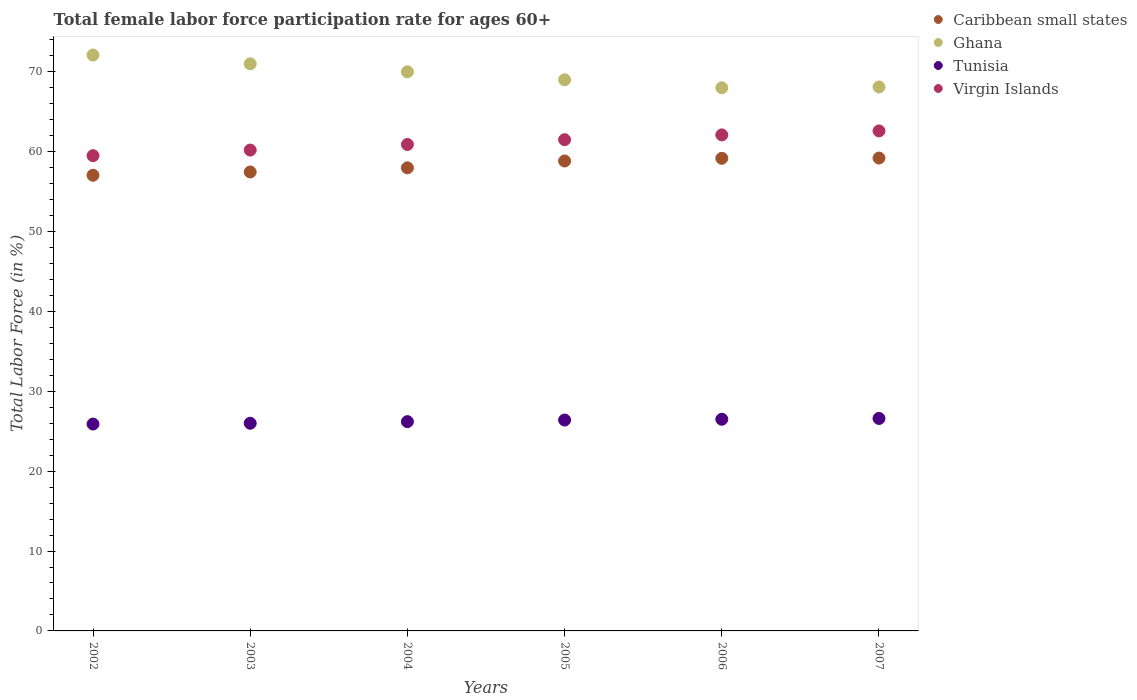How many different coloured dotlines are there?
Ensure brevity in your answer.  4. Is the number of dotlines equal to the number of legend labels?
Give a very brief answer. Yes. What is the female labor force participation rate in Ghana in 2002?
Your answer should be very brief. 72.1. Across all years, what is the maximum female labor force participation rate in Tunisia?
Offer a terse response. 26.6. In which year was the female labor force participation rate in Caribbean small states maximum?
Keep it short and to the point. 2007. What is the total female labor force participation rate in Virgin Islands in the graph?
Offer a very short reply. 366.8. What is the difference between the female labor force participation rate in Virgin Islands in 2003 and that in 2007?
Provide a succinct answer. -2.4. What is the difference between the female labor force participation rate in Caribbean small states in 2005 and the female labor force participation rate in Ghana in 2007?
Provide a short and direct response. -9.26. What is the average female labor force participation rate in Tunisia per year?
Your answer should be very brief. 26.27. In the year 2004, what is the difference between the female labor force participation rate in Ghana and female labor force participation rate in Virgin Islands?
Offer a very short reply. 9.1. In how many years, is the female labor force participation rate in Ghana greater than 46 %?
Your response must be concise. 6. What is the ratio of the female labor force participation rate in Virgin Islands in 2002 to that in 2004?
Keep it short and to the point. 0.98. Is the difference between the female labor force participation rate in Ghana in 2003 and 2004 greater than the difference between the female labor force participation rate in Virgin Islands in 2003 and 2004?
Give a very brief answer. Yes. What is the difference between the highest and the second highest female labor force participation rate in Virgin Islands?
Give a very brief answer. 0.5. What is the difference between the highest and the lowest female labor force participation rate in Ghana?
Provide a short and direct response. 4.1. Is it the case that in every year, the sum of the female labor force participation rate in Ghana and female labor force participation rate in Caribbean small states  is greater than the sum of female labor force participation rate in Virgin Islands and female labor force participation rate in Tunisia?
Ensure brevity in your answer.  Yes. Does the female labor force participation rate in Tunisia monotonically increase over the years?
Provide a succinct answer. Yes. Is the female labor force participation rate in Ghana strictly greater than the female labor force participation rate in Caribbean small states over the years?
Provide a succinct answer. Yes. Is the female labor force participation rate in Tunisia strictly less than the female labor force participation rate in Caribbean small states over the years?
Your answer should be compact. Yes. How many dotlines are there?
Offer a very short reply. 4. What is the difference between two consecutive major ticks on the Y-axis?
Provide a succinct answer. 10. Does the graph contain any zero values?
Your answer should be compact. No. Does the graph contain grids?
Your response must be concise. No. Where does the legend appear in the graph?
Your answer should be compact. Top right. How many legend labels are there?
Give a very brief answer. 4. How are the legend labels stacked?
Provide a short and direct response. Vertical. What is the title of the graph?
Provide a short and direct response. Total female labor force participation rate for ages 60+. What is the Total Labor Force (in %) of Caribbean small states in 2002?
Ensure brevity in your answer.  57.05. What is the Total Labor Force (in %) of Ghana in 2002?
Keep it short and to the point. 72.1. What is the Total Labor Force (in %) of Tunisia in 2002?
Your answer should be very brief. 25.9. What is the Total Labor Force (in %) of Virgin Islands in 2002?
Your answer should be very brief. 59.5. What is the Total Labor Force (in %) in Caribbean small states in 2003?
Offer a very short reply. 57.46. What is the Total Labor Force (in %) in Virgin Islands in 2003?
Make the answer very short. 60.2. What is the Total Labor Force (in %) in Caribbean small states in 2004?
Offer a very short reply. 57.98. What is the Total Labor Force (in %) in Ghana in 2004?
Ensure brevity in your answer.  70. What is the Total Labor Force (in %) in Tunisia in 2004?
Give a very brief answer. 26.2. What is the Total Labor Force (in %) in Virgin Islands in 2004?
Offer a very short reply. 60.9. What is the Total Labor Force (in %) of Caribbean small states in 2005?
Ensure brevity in your answer.  58.84. What is the Total Labor Force (in %) in Tunisia in 2005?
Your answer should be very brief. 26.4. What is the Total Labor Force (in %) in Virgin Islands in 2005?
Your response must be concise. 61.5. What is the Total Labor Force (in %) in Caribbean small states in 2006?
Ensure brevity in your answer.  59.17. What is the Total Labor Force (in %) in Ghana in 2006?
Your answer should be compact. 68. What is the Total Labor Force (in %) of Tunisia in 2006?
Your answer should be compact. 26.5. What is the Total Labor Force (in %) in Virgin Islands in 2006?
Provide a succinct answer. 62.1. What is the Total Labor Force (in %) in Caribbean small states in 2007?
Your response must be concise. 59.2. What is the Total Labor Force (in %) of Ghana in 2007?
Keep it short and to the point. 68.1. What is the Total Labor Force (in %) of Tunisia in 2007?
Keep it short and to the point. 26.6. What is the Total Labor Force (in %) in Virgin Islands in 2007?
Keep it short and to the point. 62.6. Across all years, what is the maximum Total Labor Force (in %) of Caribbean small states?
Offer a terse response. 59.2. Across all years, what is the maximum Total Labor Force (in %) of Ghana?
Your answer should be compact. 72.1. Across all years, what is the maximum Total Labor Force (in %) of Tunisia?
Provide a short and direct response. 26.6. Across all years, what is the maximum Total Labor Force (in %) of Virgin Islands?
Provide a succinct answer. 62.6. Across all years, what is the minimum Total Labor Force (in %) in Caribbean small states?
Keep it short and to the point. 57.05. Across all years, what is the minimum Total Labor Force (in %) of Tunisia?
Keep it short and to the point. 25.9. Across all years, what is the minimum Total Labor Force (in %) in Virgin Islands?
Offer a terse response. 59.5. What is the total Total Labor Force (in %) of Caribbean small states in the graph?
Keep it short and to the point. 349.69. What is the total Total Labor Force (in %) in Ghana in the graph?
Provide a succinct answer. 418.2. What is the total Total Labor Force (in %) in Tunisia in the graph?
Give a very brief answer. 157.6. What is the total Total Labor Force (in %) of Virgin Islands in the graph?
Your response must be concise. 366.8. What is the difference between the Total Labor Force (in %) of Caribbean small states in 2002 and that in 2003?
Provide a succinct answer. -0.41. What is the difference between the Total Labor Force (in %) in Ghana in 2002 and that in 2003?
Provide a short and direct response. 1.1. What is the difference between the Total Labor Force (in %) in Caribbean small states in 2002 and that in 2004?
Your answer should be very brief. -0.93. What is the difference between the Total Labor Force (in %) of Ghana in 2002 and that in 2004?
Keep it short and to the point. 2.1. What is the difference between the Total Labor Force (in %) in Virgin Islands in 2002 and that in 2004?
Offer a very short reply. -1.4. What is the difference between the Total Labor Force (in %) of Caribbean small states in 2002 and that in 2005?
Your answer should be compact. -1.79. What is the difference between the Total Labor Force (in %) of Tunisia in 2002 and that in 2005?
Your answer should be compact. -0.5. What is the difference between the Total Labor Force (in %) in Caribbean small states in 2002 and that in 2006?
Your answer should be very brief. -2.12. What is the difference between the Total Labor Force (in %) of Tunisia in 2002 and that in 2006?
Keep it short and to the point. -0.6. What is the difference between the Total Labor Force (in %) of Caribbean small states in 2002 and that in 2007?
Provide a succinct answer. -2.15. What is the difference between the Total Labor Force (in %) in Tunisia in 2002 and that in 2007?
Your answer should be compact. -0.7. What is the difference between the Total Labor Force (in %) in Virgin Islands in 2002 and that in 2007?
Give a very brief answer. -3.1. What is the difference between the Total Labor Force (in %) of Caribbean small states in 2003 and that in 2004?
Ensure brevity in your answer.  -0.52. What is the difference between the Total Labor Force (in %) in Ghana in 2003 and that in 2004?
Give a very brief answer. 1. What is the difference between the Total Labor Force (in %) of Caribbean small states in 2003 and that in 2005?
Make the answer very short. -1.38. What is the difference between the Total Labor Force (in %) in Caribbean small states in 2003 and that in 2006?
Your response must be concise. -1.71. What is the difference between the Total Labor Force (in %) of Tunisia in 2003 and that in 2006?
Your response must be concise. -0.5. What is the difference between the Total Labor Force (in %) in Virgin Islands in 2003 and that in 2006?
Your answer should be very brief. -1.9. What is the difference between the Total Labor Force (in %) of Caribbean small states in 2003 and that in 2007?
Your answer should be very brief. -1.74. What is the difference between the Total Labor Force (in %) of Virgin Islands in 2003 and that in 2007?
Make the answer very short. -2.4. What is the difference between the Total Labor Force (in %) in Caribbean small states in 2004 and that in 2005?
Make the answer very short. -0.86. What is the difference between the Total Labor Force (in %) of Ghana in 2004 and that in 2005?
Give a very brief answer. 1. What is the difference between the Total Labor Force (in %) in Tunisia in 2004 and that in 2005?
Your answer should be very brief. -0.2. What is the difference between the Total Labor Force (in %) in Caribbean small states in 2004 and that in 2006?
Your response must be concise. -1.19. What is the difference between the Total Labor Force (in %) in Tunisia in 2004 and that in 2006?
Provide a short and direct response. -0.3. What is the difference between the Total Labor Force (in %) of Virgin Islands in 2004 and that in 2006?
Your answer should be very brief. -1.2. What is the difference between the Total Labor Force (in %) in Caribbean small states in 2004 and that in 2007?
Keep it short and to the point. -1.22. What is the difference between the Total Labor Force (in %) in Ghana in 2004 and that in 2007?
Ensure brevity in your answer.  1.9. What is the difference between the Total Labor Force (in %) in Tunisia in 2004 and that in 2007?
Ensure brevity in your answer.  -0.4. What is the difference between the Total Labor Force (in %) in Virgin Islands in 2004 and that in 2007?
Offer a terse response. -1.7. What is the difference between the Total Labor Force (in %) of Caribbean small states in 2005 and that in 2006?
Your answer should be very brief. -0.33. What is the difference between the Total Labor Force (in %) of Ghana in 2005 and that in 2006?
Give a very brief answer. 1. What is the difference between the Total Labor Force (in %) in Caribbean small states in 2005 and that in 2007?
Provide a succinct answer. -0.37. What is the difference between the Total Labor Force (in %) in Ghana in 2005 and that in 2007?
Offer a very short reply. 0.9. What is the difference between the Total Labor Force (in %) in Virgin Islands in 2005 and that in 2007?
Offer a very short reply. -1.1. What is the difference between the Total Labor Force (in %) in Caribbean small states in 2006 and that in 2007?
Provide a short and direct response. -0.03. What is the difference between the Total Labor Force (in %) of Ghana in 2006 and that in 2007?
Make the answer very short. -0.1. What is the difference between the Total Labor Force (in %) in Tunisia in 2006 and that in 2007?
Ensure brevity in your answer.  -0.1. What is the difference between the Total Labor Force (in %) in Virgin Islands in 2006 and that in 2007?
Offer a very short reply. -0.5. What is the difference between the Total Labor Force (in %) of Caribbean small states in 2002 and the Total Labor Force (in %) of Ghana in 2003?
Give a very brief answer. -13.95. What is the difference between the Total Labor Force (in %) in Caribbean small states in 2002 and the Total Labor Force (in %) in Tunisia in 2003?
Provide a succinct answer. 31.05. What is the difference between the Total Labor Force (in %) in Caribbean small states in 2002 and the Total Labor Force (in %) in Virgin Islands in 2003?
Give a very brief answer. -3.15. What is the difference between the Total Labor Force (in %) in Ghana in 2002 and the Total Labor Force (in %) in Tunisia in 2003?
Provide a succinct answer. 46.1. What is the difference between the Total Labor Force (in %) of Ghana in 2002 and the Total Labor Force (in %) of Virgin Islands in 2003?
Your answer should be compact. 11.9. What is the difference between the Total Labor Force (in %) in Tunisia in 2002 and the Total Labor Force (in %) in Virgin Islands in 2003?
Keep it short and to the point. -34.3. What is the difference between the Total Labor Force (in %) of Caribbean small states in 2002 and the Total Labor Force (in %) of Ghana in 2004?
Your response must be concise. -12.95. What is the difference between the Total Labor Force (in %) in Caribbean small states in 2002 and the Total Labor Force (in %) in Tunisia in 2004?
Offer a very short reply. 30.85. What is the difference between the Total Labor Force (in %) of Caribbean small states in 2002 and the Total Labor Force (in %) of Virgin Islands in 2004?
Your response must be concise. -3.85. What is the difference between the Total Labor Force (in %) of Ghana in 2002 and the Total Labor Force (in %) of Tunisia in 2004?
Ensure brevity in your answer.  45.9. What is the difference between the Total Labor Force (in %) of Tunisia in 2002 and the Total Labor Force (in %) of Virgin Islands in 2004?
Ensure brevity in your answer.  -35. What is the difference between the Total Labor Force (in %) of Caribbean small states in 2002 and the Total Labor Force (in %) of Ghana in 2005?
Give a very brief answer. -11.95. What is the difference between the Total Labor Force (in %) of Caribbean small states in 2002 and the Total Labor Force (in %) of Tunisia in 2005?
Offer a terse response. 30.65. What is the difference between the Total Labor Force (in %) in Caribbean small states in 2002 and the Total Labor Force (in %) in Virgin Islands in 2005?
Your response must be concise. -4.45. What is the difference between the Total Labor Force (in %) of Ghana in 2002 and the Total Labor Force (in %) of Tunisia in 2005?
Make the answer very short. 45.7. What is the difference between the Total Labor Force (in %) of Ghana in 2002 and the Total Labor Force (in %) of Virgin Islands in 2005?
Provide a succinct answer. 10.6. What is the difference between the Total Labor Force (in %) in Tunisia in 2002 and the Total Labor Force (in %) in Virgin Islands in 2005?
Your answer should be very brief. -35.6. What is the difference between the Total Labor Force (in %) in Caribbean small states in 2002 and the Total Labor Force (in %) in Ghana in 2006?
Provide a succinct answer. -10.95. What is the difference between the Total Labor Force (in %) of Caribbean small states in 2002 and the Total Labor Force (in %) of Tunisia in 2006?
Your response must be concise. 30.55. What is the difference between the Total Labor Force (in %) in Caribbean small states in 2002 and the Total Labor Force (in %) in Virgin Islands in 2006?
Provide a succinct answer. -5.05. What is the difference between the Total Labor Force (in %) of Ghana in 2002 and the Total Labor Force (in %) of Tunisia in 2006?
Give a very brief answer. 45.6. What is the difference between the Total Labor Force (in %) of Ghana in 2002 and the Total Labor Force (in %) of Virgin Islands in 2006?
Keep it short and to the point. 10. What is the difference between the Total Labor Force (in %) in Tunisia in 2002 and the Total Labor Force (in %) in Virgin Islands in 2006?
Your answer should be compact. -36.2. What is the difference between the Total Labor Force (in %) of Caribbean small states in 2002 and the Total Labor Force (in %) of Ghana in 2007?
Ensure brevity in your answer.  -11.05. What is the difference between the Total Labor Force (in %) in Caribbean small states in 2002 and the Total Labor Force (in %) in Tunisia in 2007?
Offer a terse response. 30.45. What is the difference between the Total Labor Force (in %) in Caribbean small states in 2002 and the Total Labor Force (in %) in Virgin Islands in 2007?
Provide a succinct answer. -5.55. What is the difference between the Total Labor Force (in %) of Ghana in 2002 and the Total Labor Force (in %) of Tunisia in 2007?
Ensure brevity in your answer.  45.5. What is the difference between the Total Labor Force (in %) in Tunisia in 2002 and the Total Labor Force (in %) in Virgin Islands in 2007?
Provide a succinct answer. -36.7. What is the difference between the Total Labor Force (in %) of Caribbean small states in 2003 and the Total Labor Force (in %) of Ghana in 2004?
Make the answer very short. -12.54. What is the difference between the Total Labor Force (in %) of Caribbean small states in 2003 and the Total Labor Force (in %) of Tunisia in 2004?
Offer a very short reply. 31.26. What is the difference between the Total Labor Force (in %) of Caribbean small states in 2003 and the Total Labor Force (in %) of Virgin Islands in 2004?
Give a very brief answer. -3.44. What is the difference between the Total Labor Force (in %) of Ghana in 2003 and the Total Labor Force (in %) of Tunisia in 2004?
Offer a terse response. 44.8. What is the difference between the Total Labor Force (in %) in Ghana in 2003 and the Total Labor Force (in %) in Virgin Islands in 2004?
Provide a short and direct response. 10.1. What is the difference between the Total Labor Force (in %) in Tunisia in 2003 and the Total Labor Force (in %) in Virgin Islands in 2004?
Your answer should be compact. -34.9. What is the difference between the Total Labor Force (in %) of Caribbean small states in 2003 and the Total Labor Force (in %) of Ghana in 2005?
Your answer should be very brief. -11.54. What is the difference between the Total Labor Force (in %) of Caribbean small states in 2003 and the Total Labor Force (in %) of Tunisia in 2005?
Your answer should be very brief. 31.06. What is the difference between the Total Labor Force (in %) in Caribbean small states in 2003 and the Total Labor Force (in %) in Virgin Islands in 2005?
Give a very brief answer. -4.04. What is the difference between the Total Labor Force (in %) of Ghana in 2003 and the Total Labor Force (in %) of Tunisia in 2005?
Provide a succinct answer. 44.6. What is the difference between the Total Labor Force (in %) in Ghana in 2003 and the Total Labor Force (in %) in Virgin Islands in 2005?
Offer a very short reply. 9.5. What is the difference between the Total Labor Force (in %) of Tunisia in 2003 and the Total Labor Force (in %) of Virgin Islands in 2005?
Provide a succinct answer. -35.5. What is the difference between the Total Labor Force (in %) of Caribbean small states in 2003 and the Total Labor Force (in %) of Ghana in 2006?
Make the answer very short. -10.54. What is the difference between the Total Labor Force (in %) in Caribbean small states in 2003 and the Total Labor Force (in %) in Tunisia in 2006?
Your response must be concise. 30.96. What is the difference between the Total Labor Force (in %) of Caribbean small states in 2003 and the Total Labor Force (in %) of Virgin Islands in 2006?
Provide a succinct answer. -4.64. What is the difference between the Total Labor Force (in %) in Ghana in 2003 and the Total Labor Force (in %) in Tunisia in 2006?
Your answer should be compact. 44.5. What is the difference between the Total Labor Force (in %) in Ghana in 2003 and the Total Labor Force (in %) in Virgin Islands in 2006?
Give a very brief answer. 8.9. What is the difference between the Total Labor Force (in %) of Tunisia in 2003 and the Total Labor Force (in %) of Virgin Islands in 2006?
Keep it short and to the point. -36.1. What is the difference between the Total Labor Force (in %) in Caribbean small states in 2003 and the Total Labor Force (in %) in Ghana in 2007?
Your answer should be compact. -10.64. What is the difference between the Total Labor Force (in %) in Caribbean small states in 2003 and the Total Labor Force (in %) in Tunisia in 2007?
Keep it short and to the point. 30.86. What is the difference between the Total Labor Force (in %) in Caribbean small states in 2003 and the Total Labor Force (in %) in Virgin Islands in 2007?
Your response must be concise. -5.14. What is the difference between the Total Labor Force (in %) of Ghana in 2003 and the Total Labor Force (in %) of Tunisia in 2007?
Keep it short and to the point. 44.4. What is the difference between the Total Labor Force (in %) of Ghana in 2003 and the Total Labor Force (in %) of Virgin Islands in 2007?
Keep it short and to the point. 8.4. What is the difference between the Total Labor Force (in %) of Tunisia in 2003 and the Total Labor Force (in %) of Virgin Islands in 2007?
Provide a short and direct response. -36.6. What is the difference between the Total Labor Force (in %) of Caribbean small states in 2004 and the Total Labor Force (in %) of Ghana in 2005?
Keep it short and to the point. -11.02. What is the difference between the Total Labor Force (in %) of Caribbean small states in 2004 and the Total Labor Force (in %) of Tunisia in 2005?
Ensure brevity in your answer.  31.58. What is the difference between the Total Labor Force (in %) of Caribbean small states in 2004 and the Total Labor Force (in %) of Virgin Islands in 2005?
Offer a very short reply. -3.52. What is the difference between the Total Labor Force (in %) of Ghana in 2004 and the Total Labor Force (in %) of Tunisia in 2005?
Make the answer very short. 43.6. What is the difference between the Total Labor Force (in %) in Tunisia in 2004 and the Total Labor Force (in %) in Virgin Islands in 2005?
Keep it short and to the point. -35.3. What is the difference between the Total Labor Force (in %) of Caribbean small states in 2004 and the Total Labor Force (in %) of Ghana in 2006?
Your response must be concise. -10.02. What is the difference between the Total Labor Force (in %) in Caribbean small states in 2004 and the Total Labor Force (in %) in Tunisia in 2006?
Make the answer very short. 31.48. What is the difference between the Total Labor Force (in %) in Caribbean small states in 2004 and the Total Labor Force (in %) in Virgin Islands in 2006?
Offer a very short reply. -4.12. What is the difference between the Total Labor Force (in %) in Ghana in 2004 and the Total Labor Force (in %) in Tunisia in 2006?
Your answer should be compact. 43.5. What is the difference between the Total Labor Force (in %) in Ghana in 2004 and the Total Labor Force (in %) in Virgin Islands in 2006?
Provide a succinct answer. 7.9. What is the difference between the Total Labor Force (in %) of Tunisia in 2004 and the Total Labor Force (in %) of Virgin Islands in 2006?
Make the answer very short. -35.9. What is the difference between the Total Labor Force (in %) in Caribbean small states in 2004 and the Total Labor Force (in %) in Ghana in 2007?
Offer a terse response. -10.12. What is the difference between the Total Labor Force (in %) of Caribbean small states in 2004 and the Total Labor Force (in %) of Tunisia in 2007?
Keep it short and to the point. 31.38. What is the difference between the Total Labor Force (in %) in Caribbean small states in 2004 and the Total Labor Force (in %) in Virgin Islands in 2007?
Ensure brevity in your answer.  -4.62. What is the difference between the Total Labor Force (in %) of Ghana in 2004 and the Total Labor Force (in %) of Tunisia in 2007?
Your response must be concise. 43.4. What is the difference between the Total Labor Force (in %) of Ghana in 2004 and the Total Labor Force (in %) of Virgin Islands in 2007?
Your response must be concise. 7.4. What is the difference between the Total Labor Force (in %) of Tunisia in 2004 and the Total Labor Force (in %) of Virgin Islands in 2007?
Offer a very short reply. -36.4. What is the difference between the Total Labor Force (in %) of Caribbean small states in 2005 and the Total Labor Force (in %) of Ghana in 2006?
Your answer should be compact. -9.16. What is the difference between the Total Labor Force (in %) of Caribbean small states in 2005 and the Total Labor Force (in %) of Tunisia in 2006?
Provide a succinct answer. 32.34. What is the difference between the Total Labor Force (in %) of Caribbean small states in 2005 and the Total Labor Force (in %) of Virgin Islands in 2006?
Provide a short and direct response. -3.27. What is the difference between the Total Labor Force (in %) of Ghana in 2005 and the Total Labor Force (in %) of Tunisia in 2006?
Your answer should be very brief. 42.5. What is the difference between the Total Labor Force (in %) of Tunisia in 2005 and the Total Labor Force (in %) of Virgin Islands in 2006?
Your response must be concise. -35.7. What is the difference between the Total Labor Force (in %) of Caribbean small states in 2005 and the Total Labor Force (in %) of Ghana in 2007?
Keep it short and to the point. -9.27. What is the difference between the Total Labor Force (in %) of Caribbean small states in 2005 and the Total Labor Force (in %) of Tunisia in 2007?
Ensure brevity in your answer.  32.23. What is the difference between the Total Labor Force (in %) of Caribbean small states in 2005 and the Total Labor Force (in %) of Virgin Islands in 2007?
Provide a short and direct response. -3.77. What is the difference between the Total Labor Force (in %) of Ghana in 2005 and the Total Labor Force (in %) of Tunisia in 2007?
Ensure brevity in your answer.  42.4. What is the difference between the Total Labor Force (in %) of Ghana in 2005 and the Total Labor Force (in %) of Virgin Islands in 2007?
Offer a very short reply. 6.4. What is the difference between the Total Labor Force (in %) of Tunisia in 2005 and the Total Labor Force (in %) of Virgin Islands in 2007?
Your response must be concise. -36.2. What is the difference between the Total Labor Force (in %) in Caribbean small states in 2006 and the Total Labor Force (in %) in Ghana in 2007?
Offer a terse response. -8.93. What is the difference between the Total Labor Force (in %) of Caribbean small states in 2006 and the Total Labor Force (in %) of Tunisia in 2007?
Your answer should be very brief. 32.57. What is the difference between the Total Labor Force (in %) in Caribbean small states in 2006 and the Total Labor Force (in %) in Virgin Islands in 2007?
Give a very brief answer. -3.43. What is the difference between the Total Labor Force (in %) in Ghana in 2006 and the Total Labor Force (in %) in Tunisia in 2007?
Ensure brevity in your answer.  41.4. What is the difference between the Total Labor Force (in %) in Tunisia in 2006 and the Total Labor Force (in %) in Virgin Islands in 2007?
Provide a short and direct response. -36.1. What is the average Total Labor Force (in %) of Caribbean small states per year?
Offer a very short reply. 58.28. What is the average Total Labor Force (in %) in Ghana per year?
Keep it short and to the point. 69.7. What is the average Total Labor Force (in %) of Tunisia per year?
Keep it short and to the point. 26.27. What is the average Total Labor Force (in %) in Virgin Islands per year?
Your answer should be very brief. 61.13. In the year 2002, what is the difference between the Total Labor Force (in %) of Caribbean small states and Total Labor Force (in %) of Ghana?
Make the answer very short. -15.05. In the year 2002, what is the difference between the Total Labor Force (in %) of Caribbean small states and Total Labor Force (in %) of Tunisia?
Your answer should be compact. 31.15. In the year 2002, what is the difference between the Total Labor Force (in %) in Caribbean small states and Total Labor Force (in %) in Virgin Islands?
Your answer should be compact. -2.45. In the year 2002, what is the difference between the Total Labor Force (in %) of Ghana and Total Labor Force (in %) of Tunisia?
Your response must be concise. 46.2. In the year 2002, what is the difference between the Total Labor Force (in %) of Ghana and Total Labor Force (in %) of Virgin Islands?
Your answer should be very brief. 12.6. In the year 2002, what is the difference between the Total Labor Force (in %) of Tunisia and Total Labor Force (in %) of Virgin Islands?
Your answer should be compact. -33.6. In the year 2003, what is the difference between the Total Labor Force (in %) in Caribbean small states and Total Labor Force (in %) in Ghana?
Give a very brief answer. -13.54. In the year 2003, what is the difference between the Total Labor Force (in %) of Caribbean small states and Total Labor Force (in %) of Tunisia?
Ensure brevity in your answer.  31.46. In the year 2003, what is the difference between the Total Labor Force (in %) in Caribbean small states and Total Labor Force (in %) in Virgin Islands?
Ensure brevity in your answer.  -2.74. In the year 2003, what is the difference between the Total Labor Force (in %) in Ghana and Total Labor Force (in %) in Virgin Islands?
Your answer should be very brief. 10.8. In the year 2003, what is the difference between the Total Labor Force (in %) of Tunisia and Total Labor Force (in %) of Virgin Islands?
Ensure brevity in your answer.  -34.2. In the year 2004, what is the difference between the Total Labor Force (in %) of Caribbean small states and Total Labor Force (in %) of Ghana?
Your answer should be very brief. -12.02. In the year 2004, what is the difference between the Total Labor Force (in %) of Caribbean small states and Total Labor Force (in %) of Tunisia?
Make the answer very short. 31.78. In the year 2004, what is the difference between the Total Labor Force (in %) in Caribbean small states and Total Labor Force (in %) in Virgin Islands?
Make the answer very short. -2.92. In the year 2004, what is the difference between the Total Labor Force (in %) in Ghana and Total Labor Force (in %) in Tunisia?
Your answer should be very brief. 43.8. In the year 2004, what is the difference between the Total Labor Force (in %) of Ghana and Total Labor Force (in %) of Virgin Islands?
Your answer should be very brief. 9.1. In the year 2004, what is the difference between the Total Labor Force (in %) in Tunisia and Total Labor Force (in %) in Virgin Islands?
Offer a very short reply. -34.7. In the year 2005, what is the difference between the Total Labor Force (in %) of Caribbean small states and Total Labor Force (in %) of Ghana?
Make the answer very short. -10.16. In the year 2005, what is the difference between the Total Labor Force (in %) in Caribbean small states and Total Labor Force (in %) in Tunisia?
Make the answer very short. 32.44. In the year 2005, what is the difference between the Total Labor Force (in %) of Caribbean small states and Total Labor Force (in %) of Virgin Islands?
Provide a short and direct response. -2.67. In the year 2005, what is the difference between the Total Labor Force (in %) in Ghana and Total Labor Force (in %) in Tunisia?
Your response must be concise. 42.6. In the year 2005, what is the difference between the Total Labor Force (in %) in Tunisia and Total Labor Force (in %) in Virgin Islands?
Keep it short and to the point. -35.1. In the year 2006, what is the difference between the Total Labor Force (in %) in Caribbean small states and Total Labor Force (in %) in Ghana?
Provide a succinct answer. -8.83. In the year 2006, what is the difference between the Total Labor Force (in %) of Caribbean small states and Total Labor Force (in %) of Tunisia?
Offer a very short reply. 32.67. In the year 2006, what is the difference between the Total Labor Force (in %) in Caribbean small states and Total Labor Force (in %) in Virgin Islands?
Ensure brevity in your answer.  -2.93. In the year 2006, what is the difference between the Total Labor Force (in %) in Ghana and Total Labor Force (in %) in Tunisia?
Make the answer very short. 41.5. In the year 2006, what is the difference between the Total Labor Force (in %) of Ghana and Total Labor Force (in %) of Virgin Islands?
Your response must be concise. 5.9. In the year 2006, what is the difference between the Total Labor Force (in %) in Tunisia and Total Labor Force (in %) in Virgin Islands?
Ensure brevity in your answer.  -35.6. In the year 2007, what is the difference between the Total Labor Force (in %) in Caribbean small states and Total Labor Force (in %) in Ghana?
Provide a short and direct response. -8.9. In the year 2007, what is the difference between the Total Labor Force (in %) of Caribbean small states and Total Labor Force (in %) of Tunisia?
Give a very brief answer. 32.6. In the year 2007, what is the difference between the Total Labor Force (in %) of Caribbean small states and Total Labor Force (in %) of Virgin Islands?
Offer a very short reply. -3.4. In the year 2007, what is the difference between the Total Labor Force (in %) in Ghana and Total Labor Force (in %) in Tunisia?
Your answer should be very brief. 41.5. In the year 2007, what is the difference between the Total Labor Force (in %) of Ghana and Total Labor Force (in %) of Virgin Islands?
Your response must be concise. 5.5. In the year 2007, what is the difference between the Total Labor Force (in %) of Tunisia and Total Labor Force (in %) of Virgin Islands?
Give a very brief answer. -36. What is the ratio of the Total Labor Force (in %) in Ghana in 2002 to that in 2003?
Keep it short and to the point. 1.02. What is the ratio of the Total Labor Force (in %) of Tunisia in 2002 to that in 2003?
Your response must be concise. 1. What is the ratio of the Total Labor Force (in %) in Virgin Islands in 2002 to that in 2003?
Give a very brief answer. 0.99. What is the ratio of the Total Labor Force (in %) of Ghana in 2002 to that in 2004?
Provide a short and direct response. 1.03. What is the ratio of the Total Labor Force (in %) of Caribbean small states in 2002 to that in 2005?
Your answer should be very brief. 0.97. What is the ratio of the Total Labor Force (in %) of Ghana in 2002 to that in 2005?
Make the answer very short. 1.04. What is the ratio of the Total Labor Force (in %) of Tunisia in 2002 to that in 2005?
Offer a terse response. 0.98. What is the ratio of the Total Labor Force (in %) of Virgin Islands in 2002 to that in 2005?
Your answer should be very brief. 0.97. What is the ratio of the Total Labor Force (in %) of Caribbean small states in 2002 to that in 2006?
Make the answer very short. 0.96. What is the ratio of the Total Labor Force (in %) in Ghana in 2002 to that in 2006?
Your answer should be very brief. 1.06. What is the ratio of the Total Labor Force (in %) of Tunisia in 2002 to that in 2006?
Provide a succinct answer. 0.98. What is the ratio of the Total Labor Force (in %) in Virgin Islands in 2002 to that in 2006?
Ensure brevity in your answer.  0.96. What is the ratio of the Total Labor Force (in %) of Caribbean small states in 2002 to that in 2007?
Your answer should be compact. 0.96. What is the ratio of the Total Labor Force (in %) in Ghana in 2002 to that in 2007?
Provide a short and direct response. 1.06. What is the ratio of the Total Labor Force (in %) in Tunisia in 2002 to that in 2007?
Your answer should be very brief. 0.97. What is the ratio of the Total Labor Force (in %) of Virgin Islands in 2002 to that in 2007?
Offer a terse response. 0.95. What is the ratio of the Total Labor Force (in %) in Caribbean small states in 2003 to that in 2004?
Your answer should be very brief. 0.99. What is the ratio of the Total Labor Force (in %) in Ghana in 2003 to that in 2004?
Your response must be concise. 1.01. What is the ratio of the Total Labor Force (in %) in Tunisia in 2003 to that in 2004?
Make the answer very short. 0.99. What is the ratio of the Total Labor Force (in %) in Caribbean small states in 2003 to that in 2005?
Give a very brief answer. 0.98. What is the ratio of the Total Labor Force (in %) in Ghana in 2003 to that in 2005?
Offer a very short reply. 1.03. What is the ratio of the Total Labor Force (in %) of Tunisia in 2003 to that in 2005?
Your answer should be compact. 0.98. What is the ratio of the Total Labor Force (in %) in Virgin Islands in 2003 to that in 2005?
Offer a terse response. 0.98. What is the ratio of the Total Labor Force (in %) of Caribbean small states in 2003 to that in 2006?
Offer a very short reply. 0.97. What is the ratio of the Total Labor Force (in %) in Ghana in 2003 to that in 2006?
Offer a terse response. 1.04. What is the ratio of the Total Labor Force (in %) of Tunisia in 2003 to that in 2006?
Offer a terse response. 0.98. What is the ratio of the Total Labor Force (in %) in Virgin Islands in 2003 to that in 2006?
Make the answer very short. 0.97. What is the ratio of the Total Labor Force (in %) of Caribbean small states in 2003 to that in 2007?
Keep it short and to the point. 0.97. What is the ratio of the Total Labor Force (in %) in Ghana in 2003 to that in 2007?
Offer a very short reply. 1.04. What is the ratio of the Total Labor Force (in %) of Tunisia in 2003 to that in 2007?
Your response must be concise. 0.98. What is the ratio of the Total Labor Force (in %) in Virgin Islands in 2003 to that in 2007?
Keep it short and to the point. 0.96. What is the ratio of the Total Labor Force (in %) of Caribbean small states in 2004 to that in 2005?
Provide a succinct answer. 0.99. What is the ratio of the Total Labor Force (in %) in Ghana in 2004 to that in 2005?
Make the answer very short. 1.01. What is the ratio of the Total Labor Force (in %) in Virgin Islands in 2004 to that in 2005?
Your answer should be compact. 0.99. What is the ratio of the Total Labor Force (in %) of Caribbean small states in 2004 to that in 2006?
Provide a succinct answer. 0.98. What is the ratio of the Total Labor Force (in %) of Ghana in 2004 to that in 2006?
Offer a terse response. 1.03. What is the ratio of the Total Labor Force (in %) in Tunisia in 2004 to that in 2006?
Give a very brief answer. 0.99. What is the ratio of the Total Labor Force (in %) in Virgin Islands in 2004 to that in 2006?
Provide a succinct answer. 0.98. What is the ratio of the Total Labor Force (in %) in Caribbean small states in 2004 to that in 2007?
Your response must be concise. 0.98. What is the ratio of the Total Labor Force (in %) in Ghana in 2004 to that in 2007?
Offer a terse response. 1.03. What is the ratio of the Total Labor Force (in %) of Tunisia in 2004 to that in 2007?
Provide a short and direct response. 0.98. What is the ratio of the Total Labor Force (in %) of Virgin Islands in 2004 to that in 2007?
Offer a very short reply. 0.97. What is the ratio of the Total Labor Force (in %) of Ghana in 2005 to that in 2006?
Offer a terse response. 1.01. What is the ratio of the Total Labor Force (in %) of Virgin Islands in 2005 to that in 2006?
Give a very brief answer. 0.99. What is the ratio of the Total Labor Force (in %) in Ghana in 2005 to that in 2007?
Offer a terse response. 1.01. What is the ratio of the Total Labor Force (in %) of Virgin Islands in 2005 to that in 2007?
Offer a terse response. 0.98. What is the ratio of the Total Labor Force (in %) in Caribbean small states in 2006 to that in 2007?
Offer a terse response. 1. What is the ratio of the Total Labor Force (in %) in Ghana in 2006 to that in 2007?
Your answer should be very brief. 1. What is the difference between the highest and the second highest Total Labor Force (in %) in Caribbean small states?
Your answer should be very brief. 0.03. What is the difference between the highest and the second highest Total Labor Force (in %) of Ghana?
Provide a short and direct response. 1.1. What is the difference between the highest and the lowest Total Labor Force (in %) in Caribbean small states?
Give a very brief answer. 2.15. What is the difference between the highest and the lowest Total Labor Force (in %) of Ghana?
Offer a terse response. 4.1. What is the difference between the highest and the lowest Total Labor Force (in %) of Tunisia?
Your answer should be very brief. 0.7. 